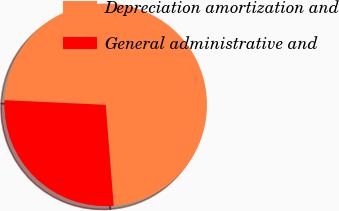<chart> <loc_0><loc_0><loc_500><loc_500><pie_chart><fcel>Depreciation amortization and<fcel>General administrative and<nl><fcel>73.0%<fcel>27.0%<nl></chart> 